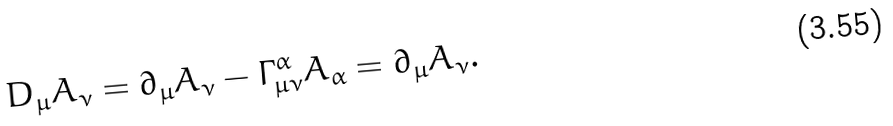Convert formula to latex. <formula><loc_0><loc_0><loc_500><loc_500>D _ { \mu } A _ { \nu } = \partial _ { \mu } A _ { \nu } - \Gamma _ { \mu \nu } ^ { \alpha } A _ { \alpha } = \partial _ { \mu } A _ { \nu } .</formula> 